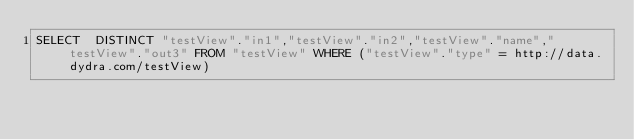Convert code to text. <code><loc_0><loc_0><loc_500><loc_500><_SQL_>SELECT  DISTINCT "testView"."in1","testView"."in2","testView"."name","testView"."out3" FROM "testView" WHERE ("testView"."type" = http://data.dydra.com/testView)
</code> 